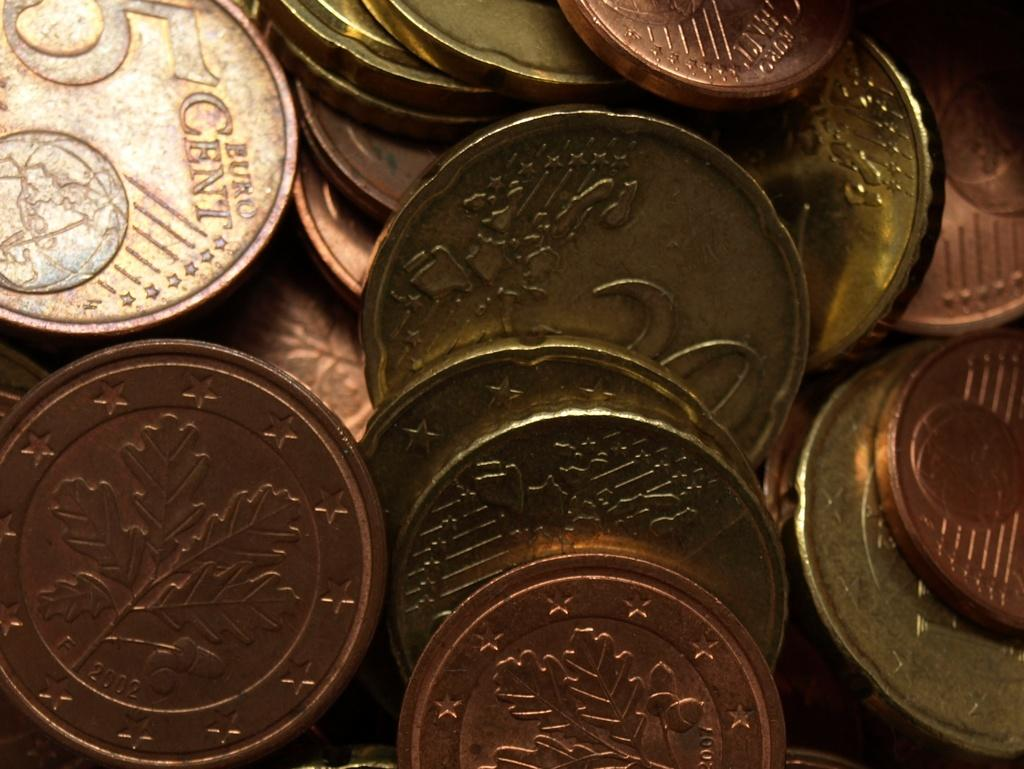<image>
Provide a brief description of the given image. A coin worth five cents is in a pile with other coins. 